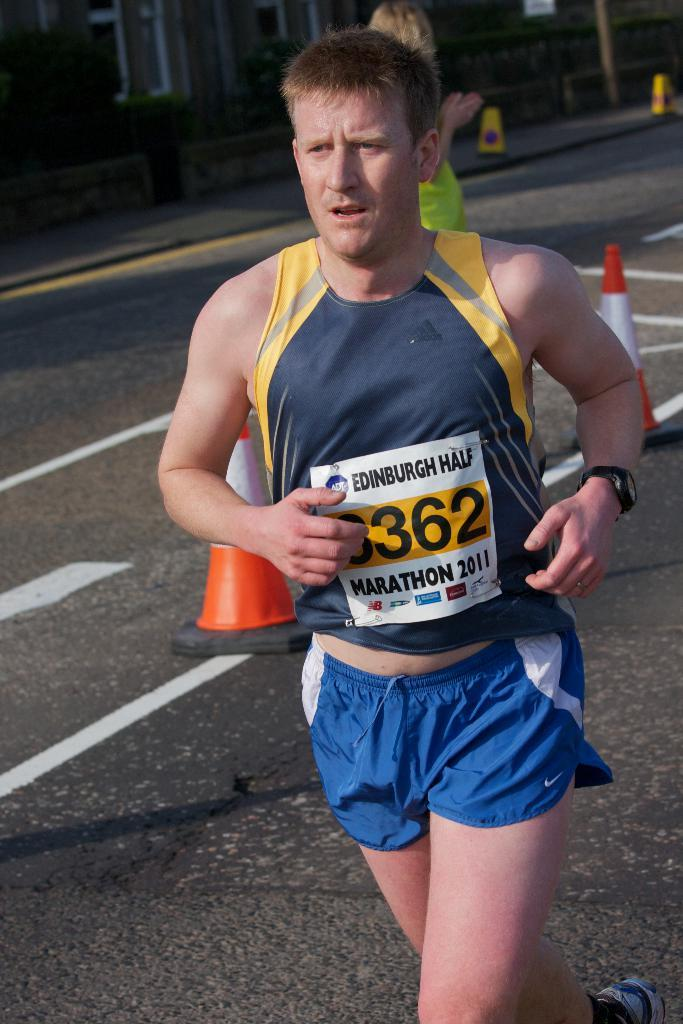<image>
Describe the image concisely. Marathon runner with a square tag on the front of his shirt with Edinburgh half in black letters. 